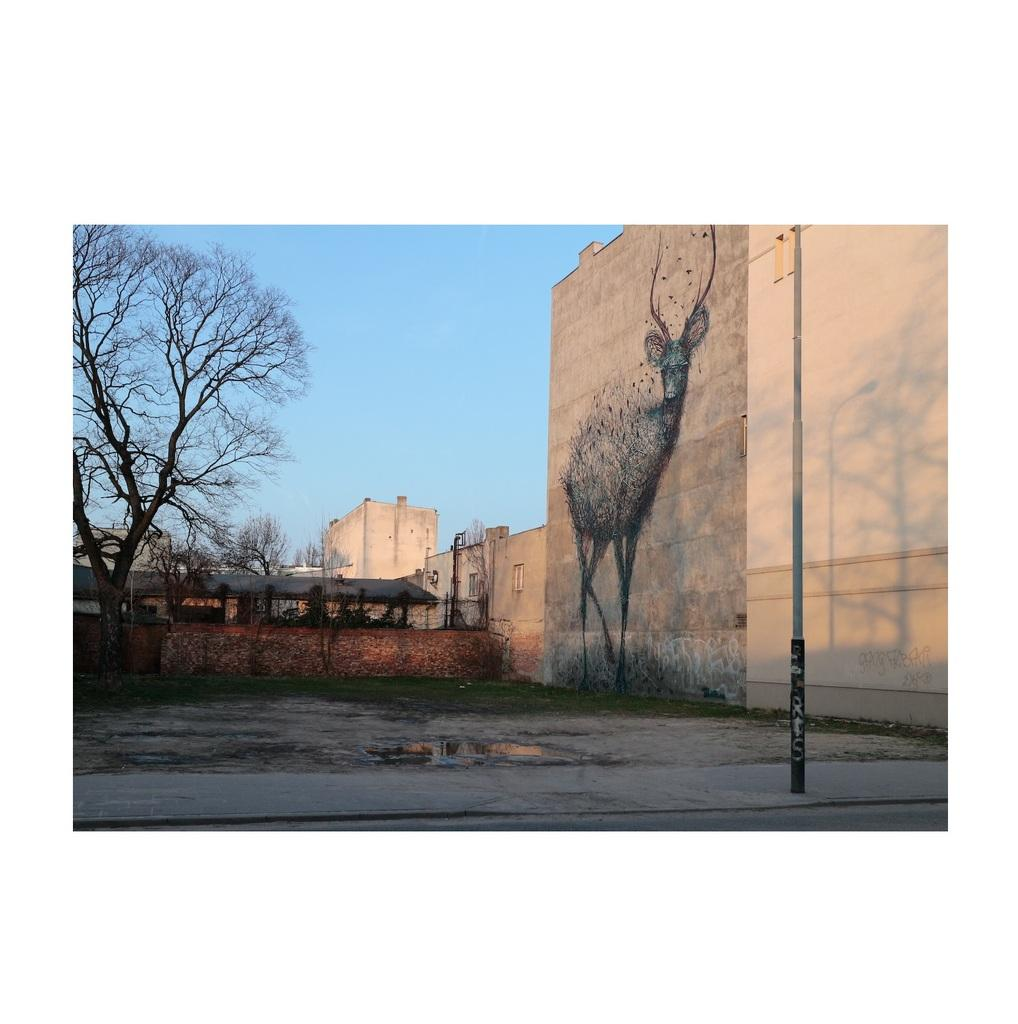What is depicted on the wall in the image? There is art on the wall in the image. What can be seen beneath the wall in the image? The ground is visible in the image. What object is present in the image that might be used for support or guidance? There is a pole in the image. What type of vegetation is present in the image? There is grass in the image. What type of structures can be seen in the image? There are houses in the image. What other natural elements are present in the image? There are trees in the image. What is visible above the wall in the image? The sky is visible in the image. What is the title of the art displayed on the wall in the image? There is no information provided about the title of the art in the image. How does the pollution affect the grass in the image? There is no mention of pollution in the image, so its effect on the grass cannot be determined. 